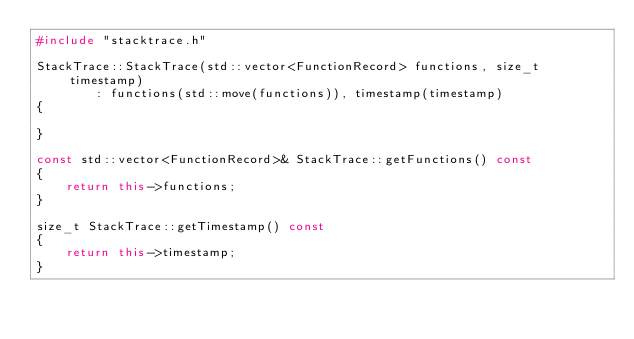Convert code to text. <code><loc_0><loc_0><loc_500><loc_500><_C++_>#include "stacktrace.h"

StackTrace::StackTrace(std::vector<FunctionRecord> functions, size_t timestamp)
        : functions(std::move(functions)), timestamp(timestamp)
{

}

const std::vector<FunctionRecord>& StackTrace::getFunctions() const
{
    return this->functions;
}

size_t StackTrace::getTimestamp() const
{
    return this->timestamp;
}
</code> 